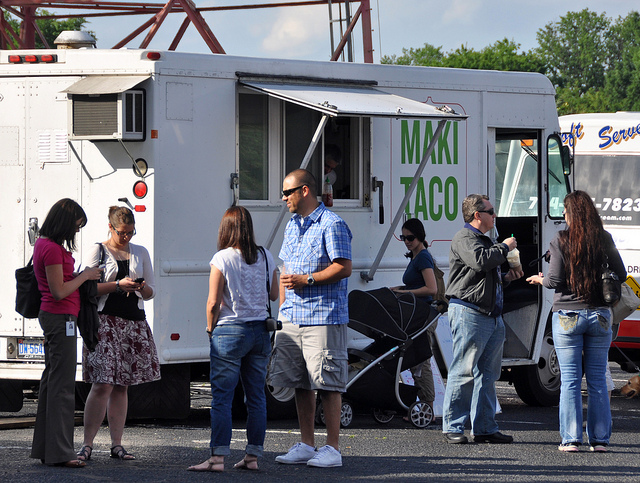Please transcribe the text in this image. MAKI TACO oft Serv 564 DR 7823 7 